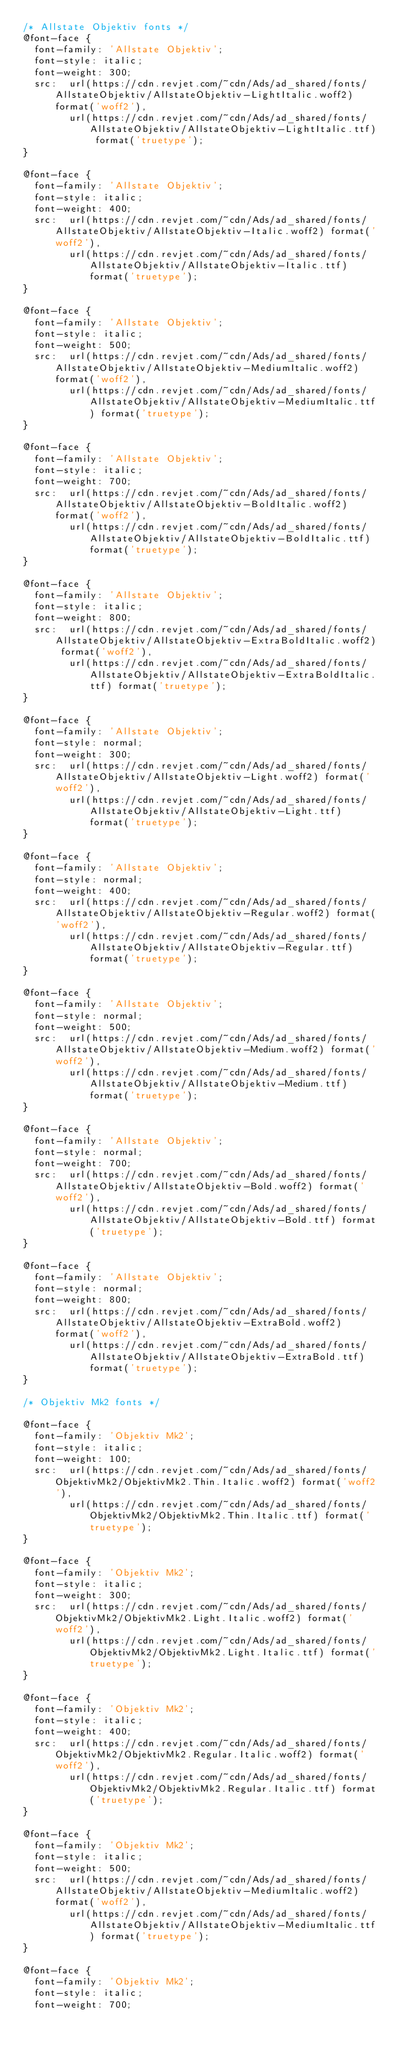<code> <loc_0><loc_0><loc_500><loc_500><_CSS_>/* Allstate Objektiv fonts */
@font-face {
  font-family: 'Allstate Objektiv';
  font-style: italic;
  font-weight: 300;
  src:  url(https://cdn.revjet.com/~cdn/Ads/ad_shared/fonts/AllstateObjektiv/AllstateObjektiv-LightItalic.woff2) format('woff2'),
        url(https://cdn.revjet.com/~cdn/Ads/ad_shared/fonts/AllstateObjektiv/AllstateObjektiv-LightItalic.ttf) format('truetype');
}

@font-face {
  font-family: 'Allstate Objektiv';
  font-style: italic;
  font-weight: 400;
  src:  url(https://cdn.revjet.com/~cdn/Ads/ad_shared/fonts/AllstateObjektiv/AllstateObjektiv-Italic.woff2) format('woff2'),
        url(https://cdn.revjet.com/~cdn/Ads/ad_shared/fonts/AllstateObjektiv/AllstateObjektiv-Italic.ttf) format('truetype');
}

@font-face {
  font-family: 'Allstate Objektiv';
  font-style: italic;
  font-weight: 500;
  src:  url(https://cdn.revjet.com/~cdn/Ads/ad_shared/fonts/AllstateObjektiv/AllstateObjektiv-MediumItalic.woff2) format('woff2'),
        url(https://cdn.revjet.com/~cdn/Ads/ad_shared/fonts/AllstateObjektiv/AllstateObjektiv-MediumItalic.ttf) format('truetype');
}

@font-face {
  font-family: 'Allstate Objektiv';
  font-style: italic;
  font-weight: 700;
  src:  url(https://cdn.revjet.com/~cdn/Ads/ad_shared/fonts/AllstateObjektiv/AllstateObjektiv-BoldItalic.woff2) format('woff2'),
        url(https://cdn.revjet.com/~cdn/Ads/ad_shared/fonts/AllstateObjektiv/AllstateObjektiv-BoldItalic.ttf) format('truetype');
}

@font-face {
  font-family: 'Allstate Objektiv';
  font-style: italic;
  font-weight: 800;
  src:  url(https://cdn.revjet.com/~cdn/Ads/ad_shared/fonts/AllstateObjektiv/AllstateObjektiv-ExtraBoldItalic.woff2) format('woff2'),
        url(https://cdn.revjet.com/~cdn/Ads/ad_shared/fonts/AllstateObjektiv/AllstateObjektiv-ExtraBoldItalic.ttf) format('truetype');
}

@font-face {
  font-family: 'Allstate Objektiv';
  font-style: normal;
  font-weight: 300;
  src:  url(https://cdn.revjet.com/~cdn/Ads/ad_shared/fonts/AllstateObjektiv/AllstateObjektiv-Light.woff2) format('woff2'),
        url(https://cdn.revjet.com/~cdn/Ads/ad_shared/fonts/AllstateObjektiv/AllstateObjektiv-Light.ttf) format('truetype');
}

@font-face {
  font-family: 'Allstate Objektiv';
  font-style: normal;
  font-weight: 400;
  src:  url(https://cdn.revjet.com/~cdn/Ads/ad_shared/fonts/AllstateObjektiv/AllstateObjektiv-Regular.woff2) format('woff2'),
        url(https://cdn.revjet.com/~cdn/Ads/ad_shared/fonts/AllstateObjektiv/AllstateObjektiv-Regular.ttf) format('truetype');
}

@font-face {
  font-family: 'Allstate Objektiv';
  font-style: normal;
  font-weight: 500;
  src:  url(https://cdn.revjet.com/~cdn/Ads/ad_shared/fonts/AllstateObjektiv/AllstateObjektiv-Medium.woff2) format('woff2'),
        url(https://cdn.revjet.com/~cdn/Ads/ad_shared/fonts/AllstateObjektiv/AllstateObjektiv-Medium.ttf) format('truetype');
}

@font-face {
  font-family: 'Allstate Objektiv';
  font-style: normal;
  font-weight: 700;
  src:  url(https://cdn.revjet.com/~cdn/Ads/ad_shared/fonts/AllstateObjektiv/AllstateObjektiv-Bold.woff2) format('woff2'),
        url(https://cdn.revjet.com/~cdn/Ads/ad_shared/fonts/AllstateObjektiv/AllstateObjektiv-Bold.ttf) format('truetype');
}

@font-face {
  font-family: 'Allstate Objektiv';
  font-style: normal;
  font-weight: 800;
  src:  url(https://cdn.revjet.com/~cdn/Ads/ad_shared/fonts/AllstateObjektiv/AllstateObjektiv-ExtraBold.woff2) format('woff2'),
        url(https://cdn.revjet.com/~cdn/Ads/ad_shared/fonts/AllstateObjektiv/AllstateObjektiv-ExtraBold.ttf) format('truetype');
}

/* Objektiv Mk2 fonts */

@font-face {
  font-family: 'Objektiv Mk2';
  font-style: italic;
  font-weight: 100;
  src:  url(https://cdn.revjet.com/~cdn/Ads/ad_shared/fonts/ObjektivMk2/ObjektivMk2.Thin.Italic.woff2) format('woff2'),
        url(https://cdn.revjet.com/~cdn/Ads/ad_shared/fonts/ObjektivMk2/ObjektivMk2.Thin.Italic.ttf) format('truetype');
}

@font-face {
  font-family: 'Objektiv Mk2';
  font-style: italic;
  font-weight: 300;
  src:  url(https://cdn.revjet.com/~cdn/Ads/ad_shared/fonts/ObjektivMk2/ObjektivMk2.Light.Italic.woff2) format('woff2'),
        url(https://cdn.revjet.com/~cdn/Ads/ad_shared/fonts/ObjektivMk2/ObjektivMk2.Light.Italic.ttf) format('truetype');
}

@font-face {
  font-family: 'Objektiv Mk2';
  font-style: italic;
  font-weight: 400;
  src:  url(https://cdn.revjet.com/~cdn/Ads/ad_shared/fonts/ObjektivMk2/ObjektivMk2.Regular.Italic.woff2) format('woff2'),
        url(https://cdn.revjet.com/~cdn/Ads/ad_shared/fonts/ObjektivMk2/ObjektivMk2.Regular.Italic.ttf) format('truetype');
}

@font-face {
  font-family: 'Objektiv Mk2';
  font-style: italic;
  font-weight: 500;
  src:  url(https://cdn.revjet.com/~cdn/Ads/ad_shared/fonts/AllstateObjektiv/AllstateObjektiv-MediumItalic.woff2) format('woff2'),
        url(https://cdn.revjet.com/~cdn/Ads/ad_shared/fonts/AllstateObjektiv/AllstateObjektiv-MediumItalic.ttf) format('truetype');
}

@font-face {
  font-family: 'Objektiv Mk2';
  font-style: italic;
  font-weight: 700;</code> 